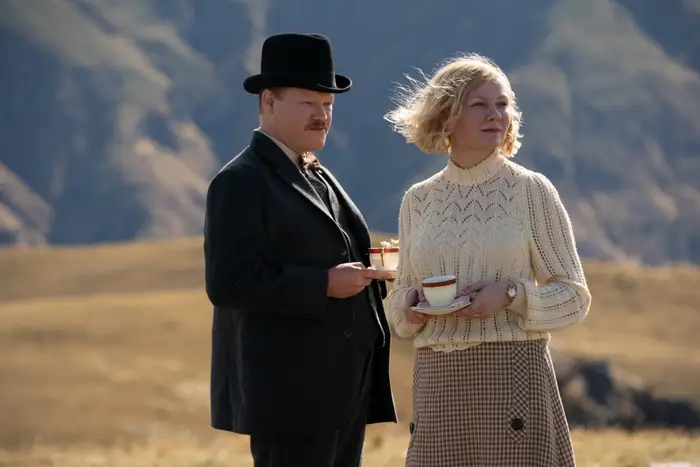What might be the significance of the setting in this scene? The rugged, expansive backdrop in the scene symbolizes both the emotional and physical landscapes the characters navigate. This isolating environment might represent the challenges or internal conflicts the characters face, emphasizing themes of solitude and introspection prevalent in their narratives. 